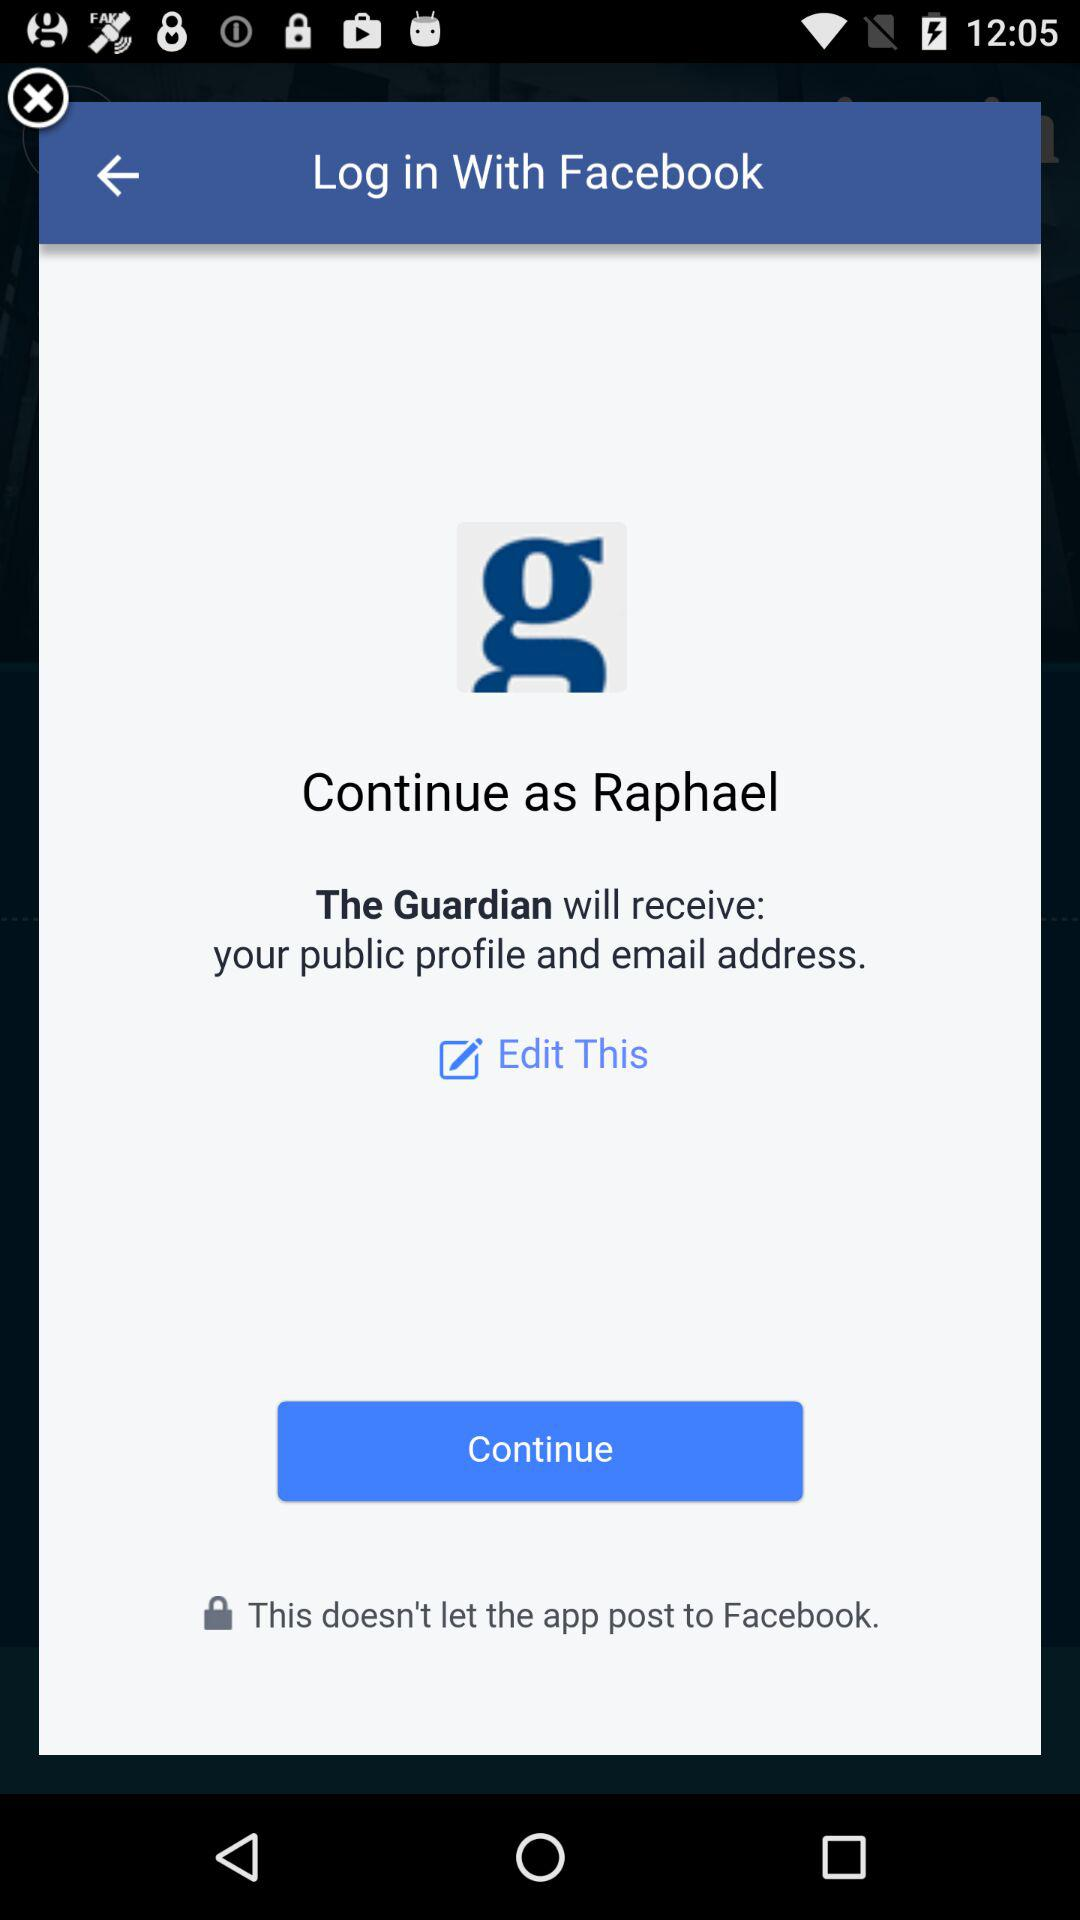What is the user name? The user name is Raphael. 